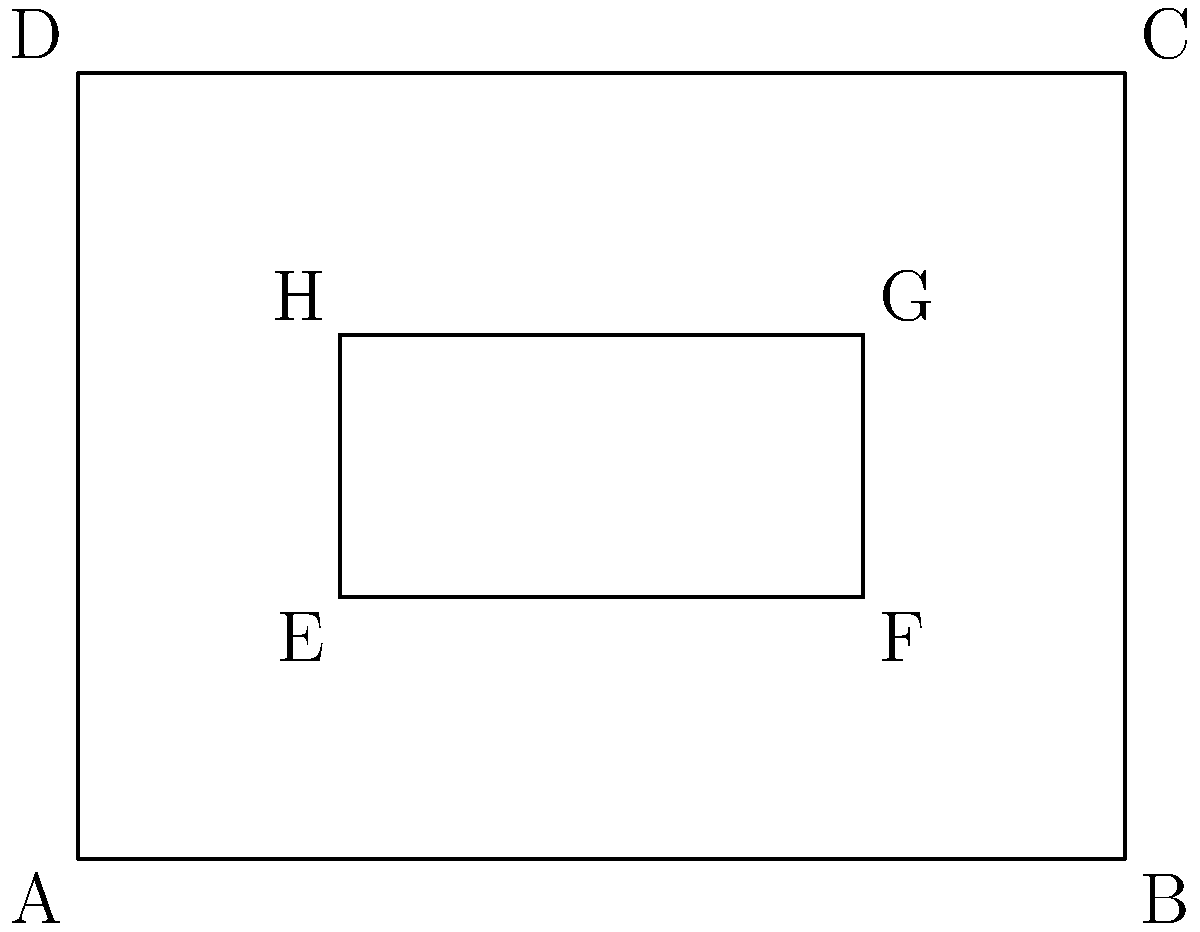In your research on the geometric patterns of vintage car grilles, you come across a simplified representation of a classic 1930s grille design. The outer rectangle ABCD represents the entire grille, while the inner rectangle EFGH represents the central design element. If the area of rectangle ABCD is 12 square units and the area of rectangle EFGH is 2 square units, what is the ratio of the perimeter of EFGH to the perimeter of ABCD? Let's approach this step-by-step:

1) First, we need to find the dimensions of both rectangles.

   For rectangle ABCD:
   Area = length × width = 12 sq units
   Let's say length = 4 units and width = 3 units (4 × 3 = 12)

   For rectangle EFGH:
   Area = length × width = 2 sq units
   Let's say length = 2 units and width = 1 unit (2 × 1 = 2)

2) Now, let's calculate the perimeters:

   Perimeter of ABCD = 2(length + width) = 2(4 + 3) = 2(7) = 14 units

   Perimeter of EFGH = 2(length + width) = 2(2 + 1) = 2(3) = 6 units

3) The ratio of the perimeter of EFGH to the perimeter of ABCD is:

   $\frac{\text{Perimeter of EFGH}}{\text{Perimeter of ABCD}} = \frac{6}{14} = \frac{3}{7}$

This ratio represents how the central design element's outline compares to the overall grille outline, which could be an interesting point in discussing the aesthetic balance in vintage car grille designs.
Answer: $\frac{3}{7}$ 